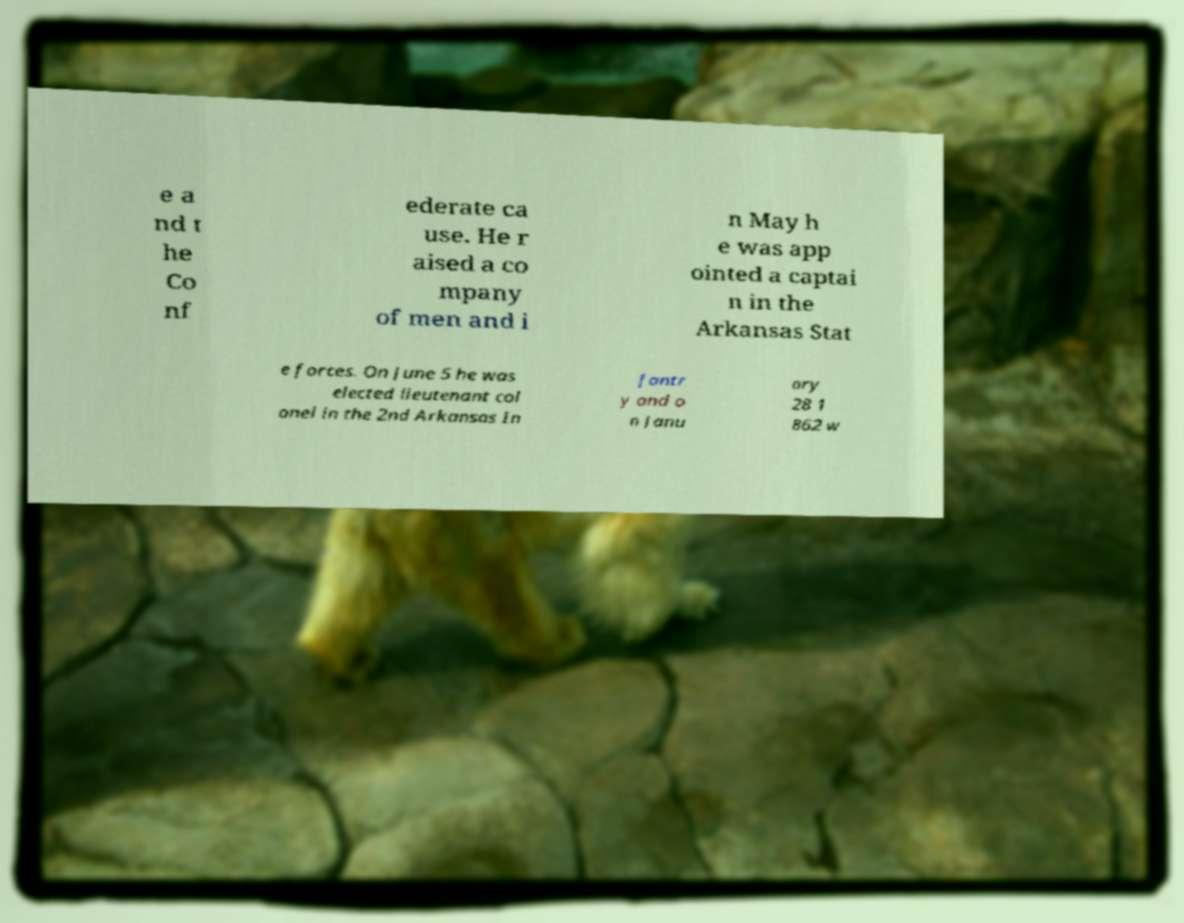Can you accurately transcribe the text from the provided image for me? e a nd t he Co nf ederate ca use. He r aised a co mpany of men and i n May h e was app ointed a captai n in the Arkansas Stat e forces. On June 5 he was elected lieutenant col onel in the 2nd Arkansas In fantr y and o n Janu ary 28 1 862 w 